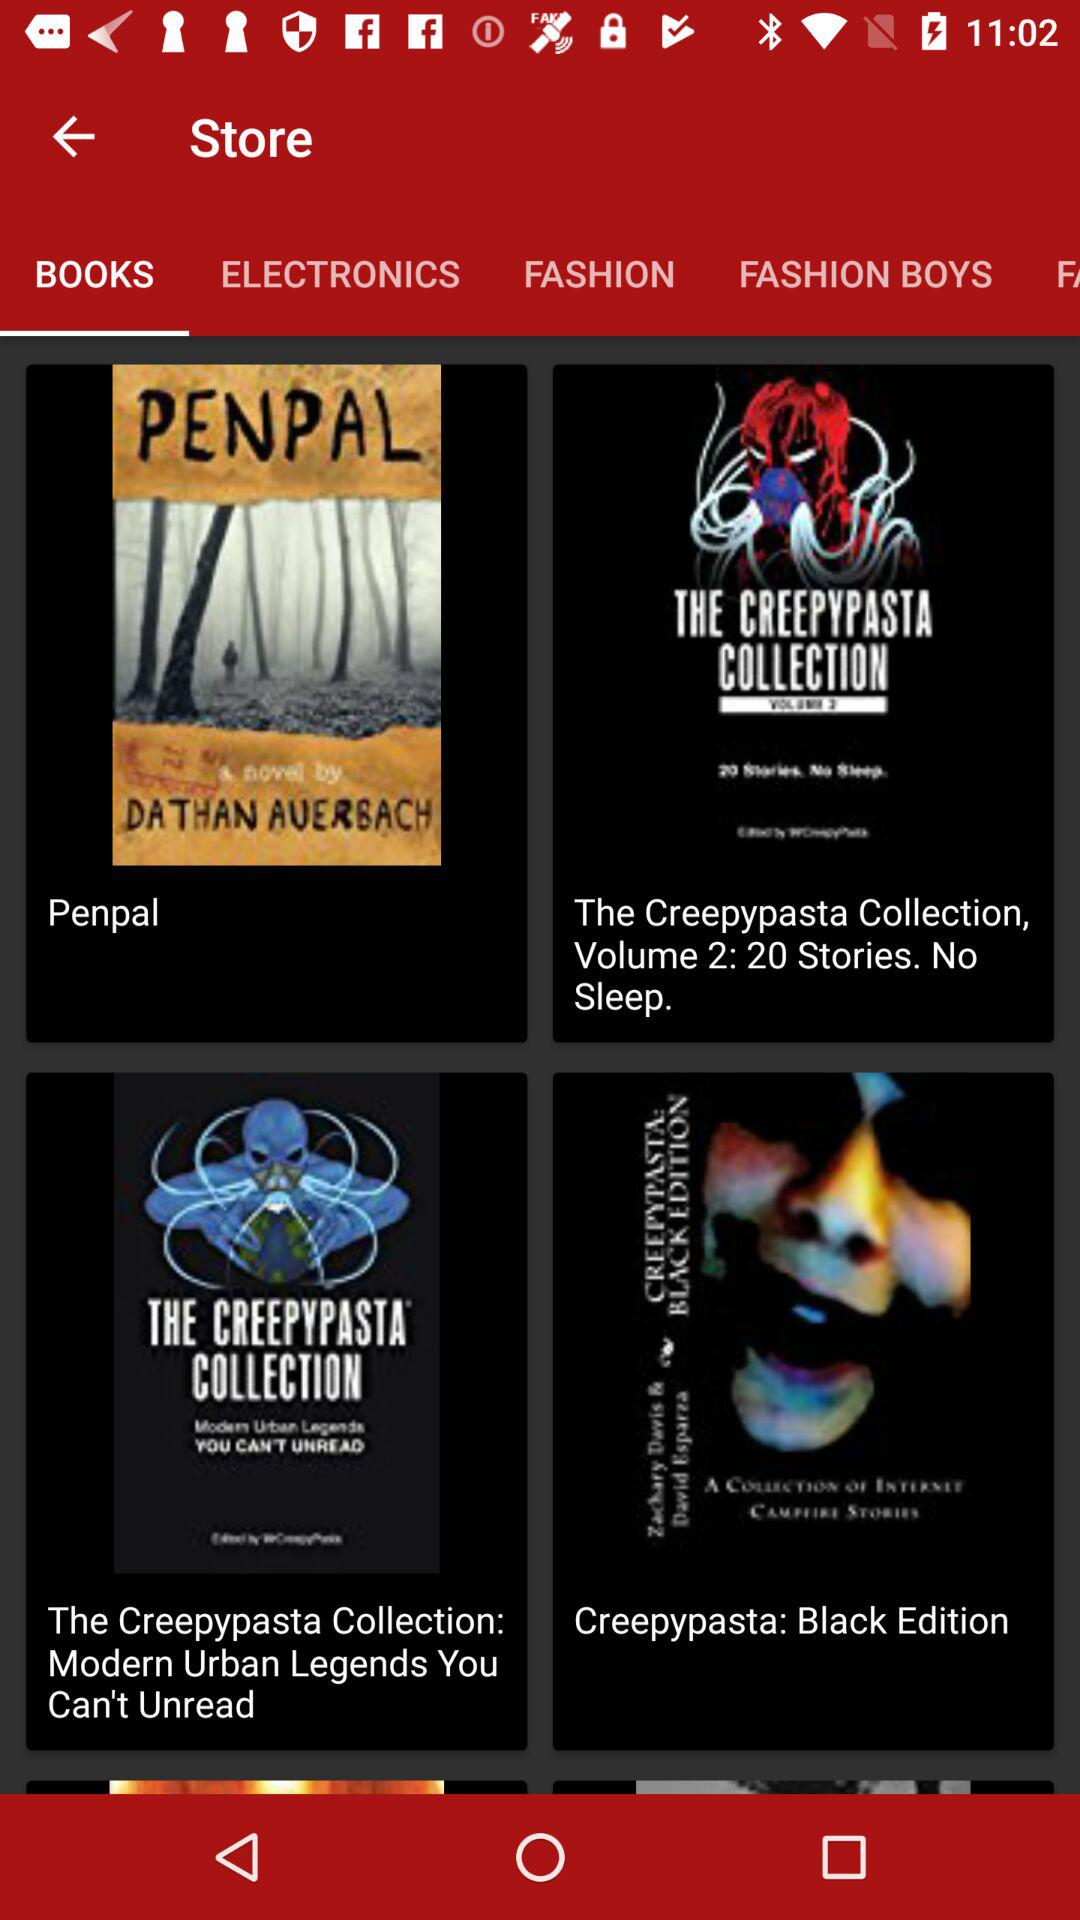Which items are listed in "ELECTRONICS"?
When the provided information is insufficient, respond with <no answer>. <no answer> 